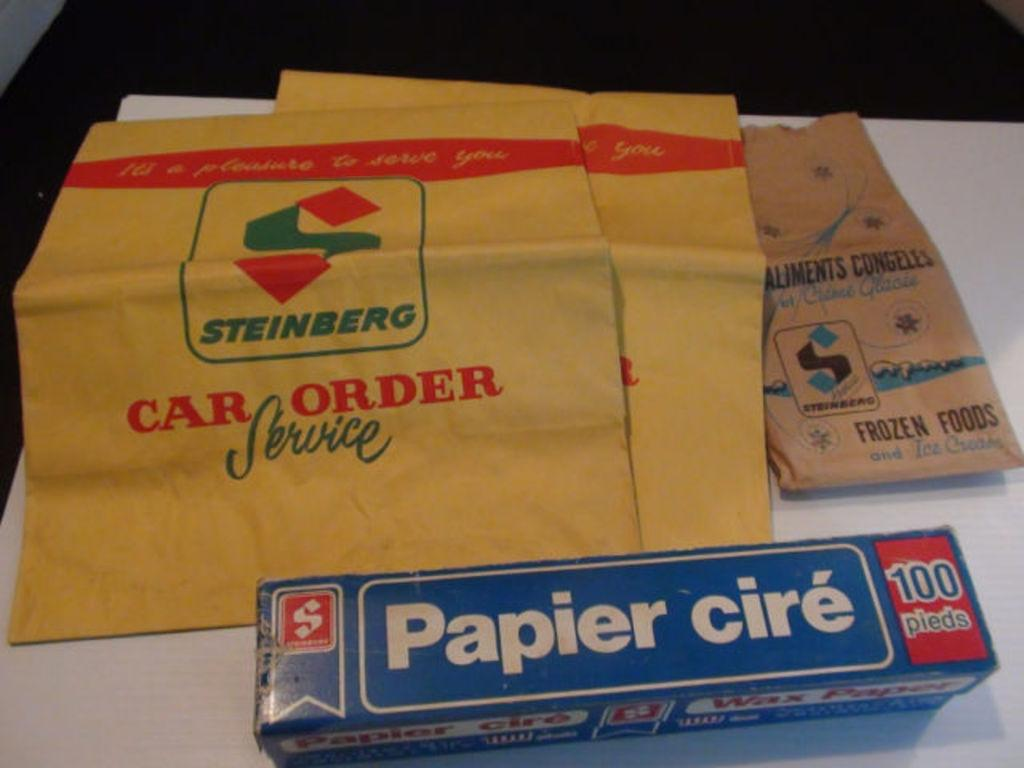<image>
Provide a brief description of the given image. An envelope with car order source on it next to a blue box. 